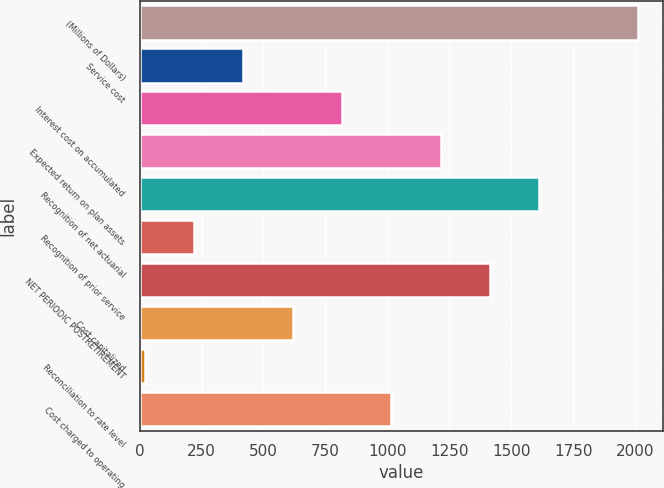Convert chart to OTSL. <chart><loc_0><loc_0><loc_500><loc_500><bar_chart><fcel>(Millions of Dollars)<fcel>Service cost<fcel>Interest cost on accumulated<fcel>Expected return on plan assets<fcel>Recognition of net actuarial<fcel>Recognition of prior service<fcel>NET PERIODIC POSTRETIREMENT<fcel>Cost capitalized<fcel>Reconciliation to rate level<fcel>Cost charged to operating<nl><fcel>2012<fcel>418.4<fcel>816.8<fcel>1215.2<fcel>1613.6<fcel>219.2<fcel>1414.4<fcel>617.6<fcel>20<fcel>1016<nl></chart> 